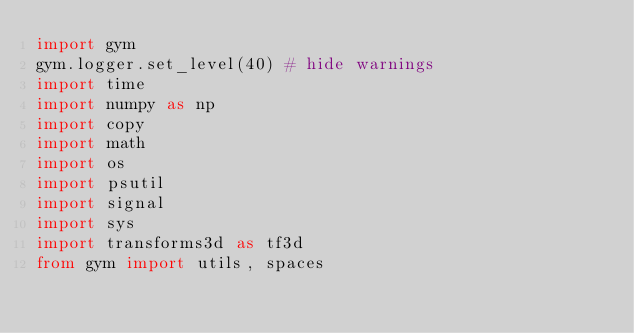Convert code to text. <code><loc_0><loc_0><loc_500><loc_500><_Python_>import gym
gym.logger.set_level(40) # hide warnings
import time
import numpy as np
import copy
import math
import os
import psutil
import signal
import sys
import transforms3d as tf3d
from gym import utils, spaces</code> 